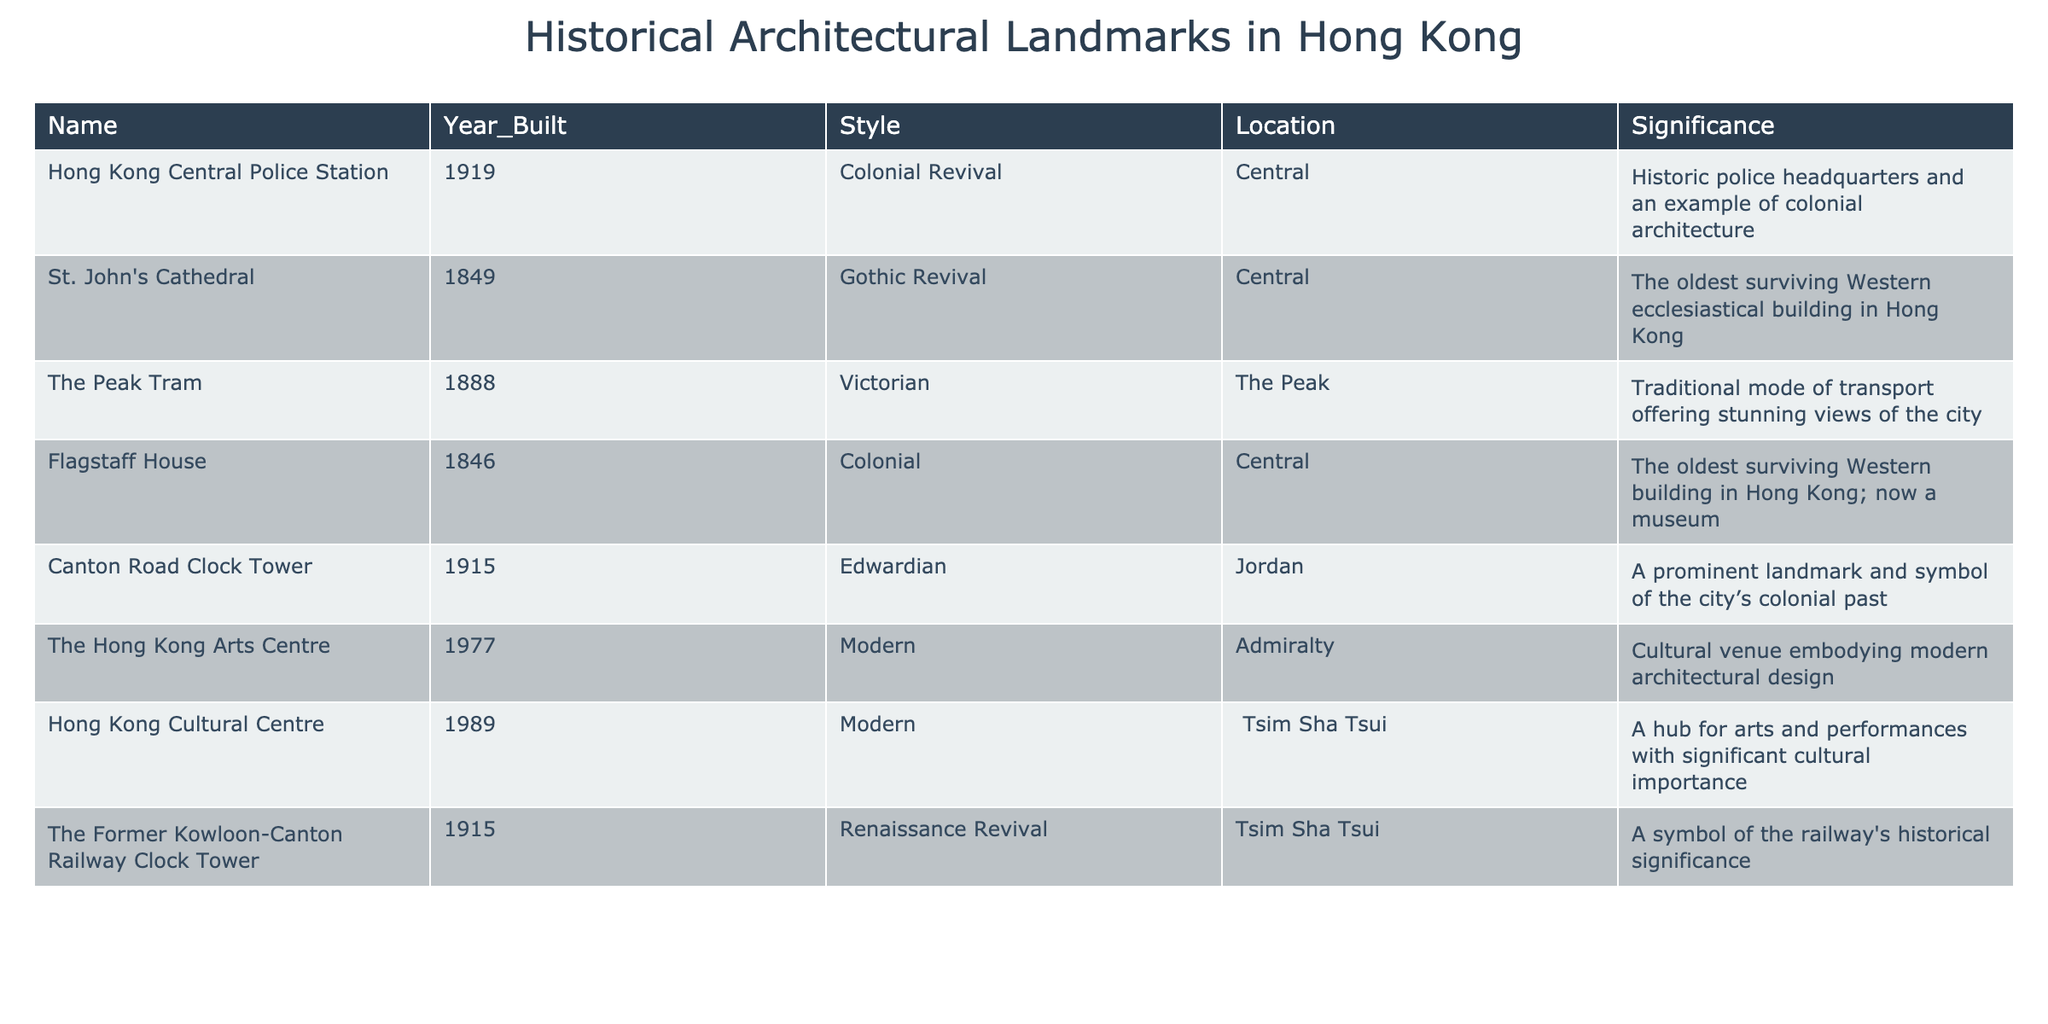What is the oldest surviving Western ecclesiastical building in Hong Kong? According to the table, "St. John's Cathedral," built in 1849, is noted as the oldest surviving Western ecclesiastical building in Hong Kong.
Answer: St. John's Cathedral How many landmarks were built in the 1910s? The table lists two landmarks built in the 1910s: the Canton Road Clock Tower (1915) and the Former Kowloon-Canton Railway Clock Tower (1915). Counting these gives a total of 2 landmarks.
Answer: 2 What architectural style is the Hong Kong Cultural Centre? The table states that the Hong Kong Cultural Centre, built in 1989, exemplifies modern architectural style.
Answer: Modern Which building is the oldest from the presented data? From the table, Flagstaff House built in 1846 is the oldest building in the list provided.
Answer: Flagstaff House How many buildings were constructed before 1900? By examining the table, we find three buildings built before 1900: St. John's Cathedral (1849), Flagstaff House (1846), and The Peak Tram (1888). Therefore, the total is 3.
Answer: 3 Is the Hong Kong Arts Centre the only structure built in the 1970s? The table indicates that the Hong Kong Arts Centre was built in 1977. It appears to be the only structure listed from that decade, indicating it is the only one from the 1970s in this data set.
Answer: Yes What year was the Canton Road Clock Tower built? The table indicates that the Canton Road Clock Tower was constructed in 1915.
Answer: 1915 Which style is represented by the largest number of buildings in the table? Upon reviewing the table, there are three buildings in the Modern style (Hong Kong Cultural Centre, The Hong Kong Arts Centre) and two each in Colonial and Gothic Revival styles. Therefore, Modern is the style with the largest representation.
Answer: Modern What is the significance of the Former Kowloon-Canton Railway Clock Tower? As per the table, the Former Kowloon-Canton Railway Clock Tower is noted as a symbol of the railway's historical significance, reflecting its cultural importance.
Answer: A symbol of railway significance How many buildings are categorized as Colonial in style? The table lists two buildings with Colonial style: Flagstaff House (1846) and Hong Kong Central Police Station (1919). Hence, the total number is 2.
Answer: 2 Which landmark was built last among those in the table? The table shows that the last landmark built is the Hong Kong Cultural Centre in 1989, making it the most recent.
Answer: Hong Kong Cultural Centre 